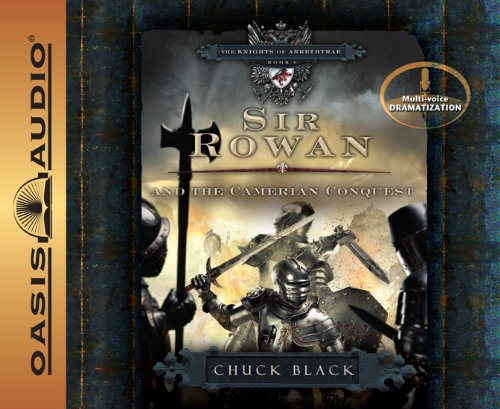Is this book related to Teen & Young Adult? Yes, this book is indeed related to the Teen & Young Adult genre, designed to captivate youth with its dynamic plotting and character development. 